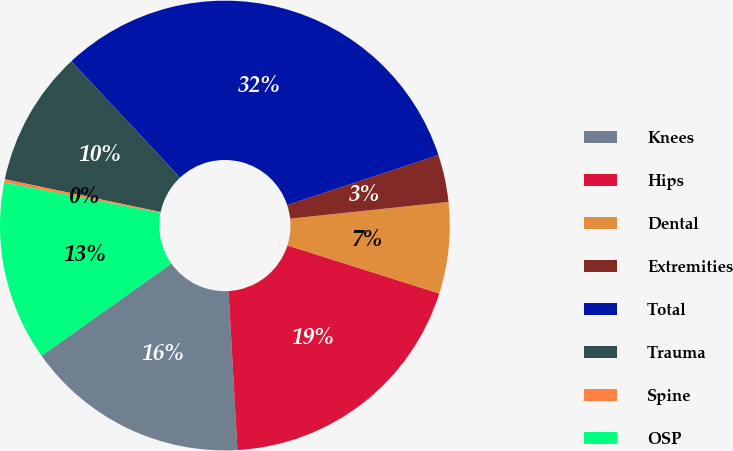<chart> <loc_0><loc_0><loc_500><loc_500><pie_chart><fcel>Knees<fcel>Hips<fcel>Dental<fcel>Extremities<fcel>Total<fcel>Trauma<fcel>Spine<fcel>OSP<nl><fcel>16.06%<fcel>19.23%<fcel>6.56%<fcel>3.4%<fcel>31.89%<fcel>9.73%<fcel>0.23%<fcel>12.9%<nl></chart> 